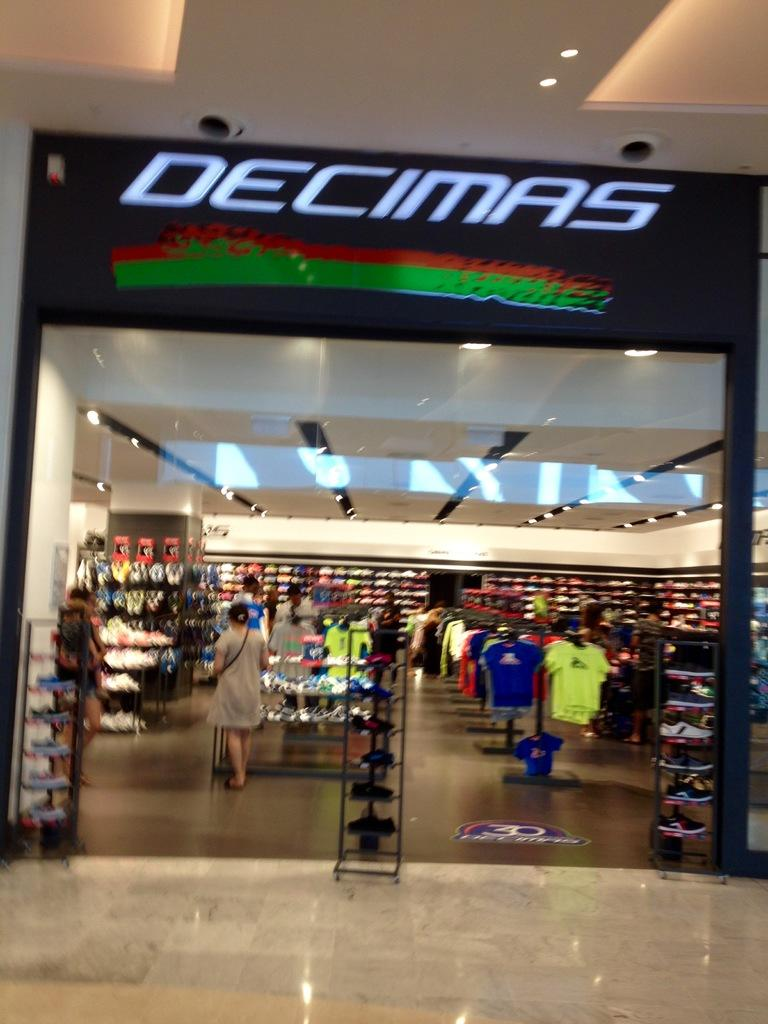What type of establishment is shown in the image? The image depicts the inside view of a store. What type of products can be found in the store? There are clothes and shoes in the store. Are there any people present in the store? Yes, there are people in the store. How is the store illuminated? The store has lights. What other items can be found in the store besides clothes and shoes? There are other things in the store. What can be seen at the top of the image? There is a hoarding visible at the top of the image. What size of pail is used to water the scarecrow in the image? There is no pail or scarecrow present in the image; it depicts the inside view of a store. 